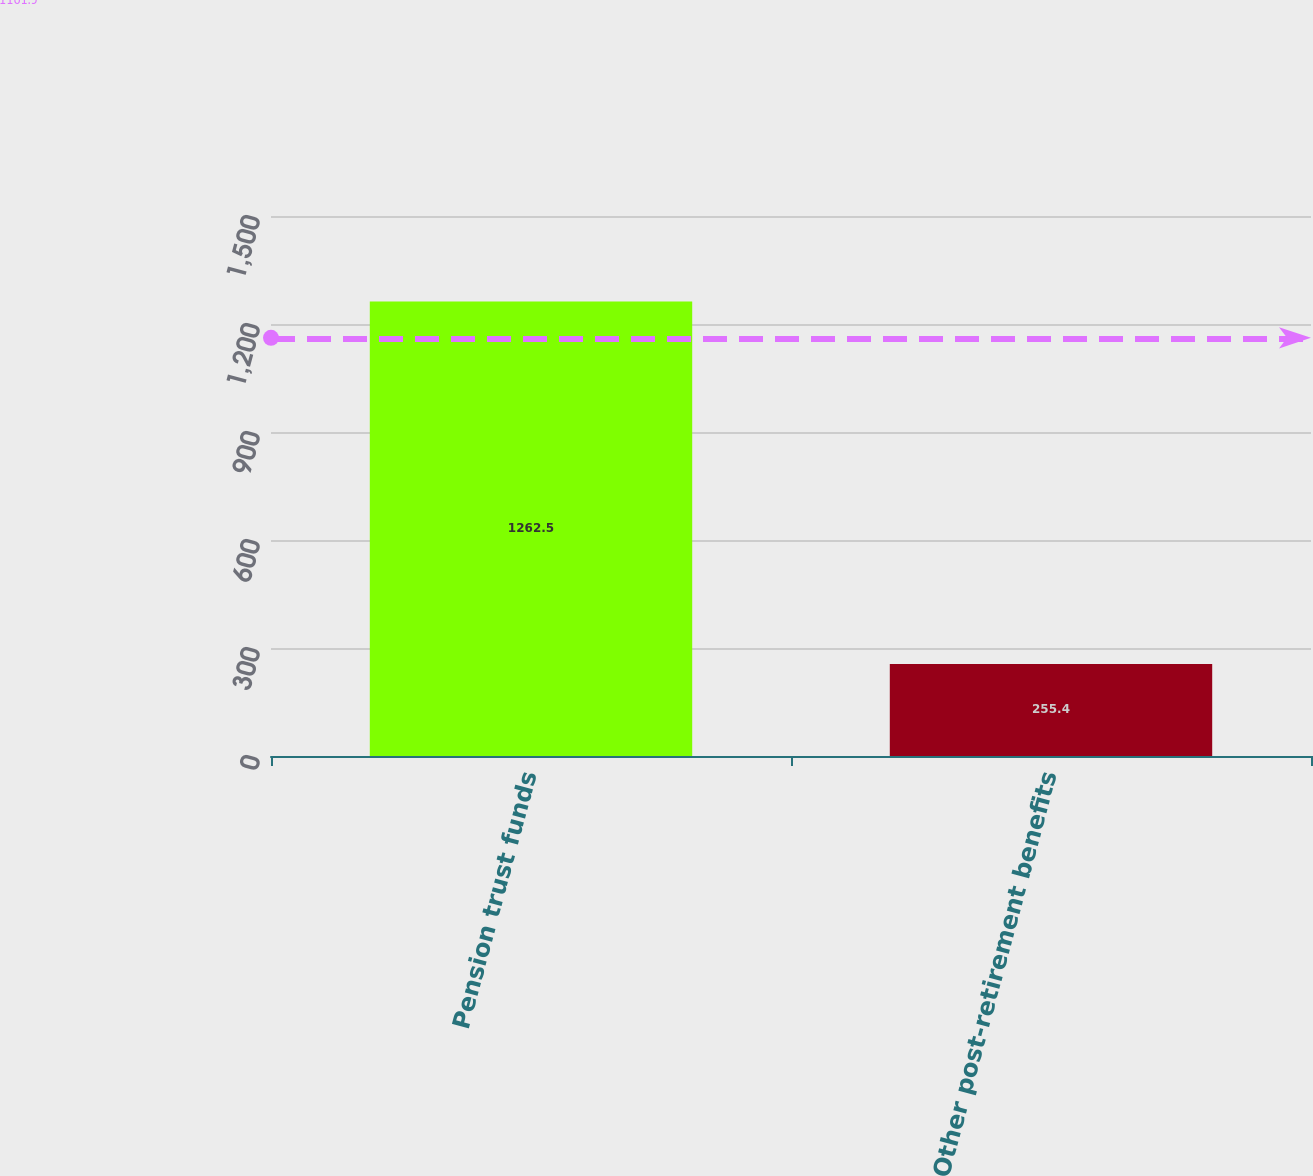Convert chart. <chart><loc_0><loc_0><loc_500><loc_500><bar_chart><fcel>Pension trust funds<fcel>Other post-retirement benefits<nl><fcel>1262.5<fcel>255.4<nl></chart> 